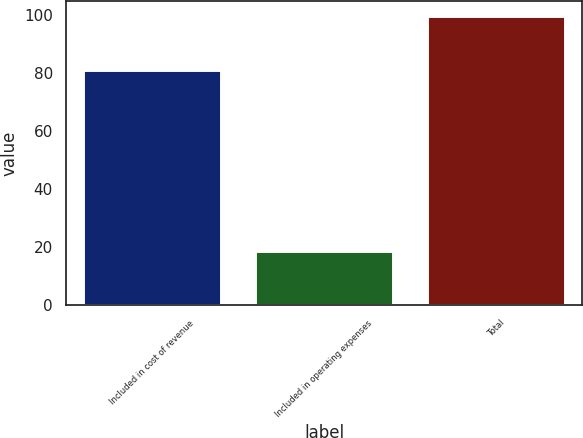Convert chart. <chart><loc_0><loc_0><loc_500><loc_500><bar_chart><fcel>Included in cost of revenue<fcel>Included in operating expenses<fcel>Total<nl><fcel>81.3<fcel>18.6<fcel>99.9<nl></chart> 